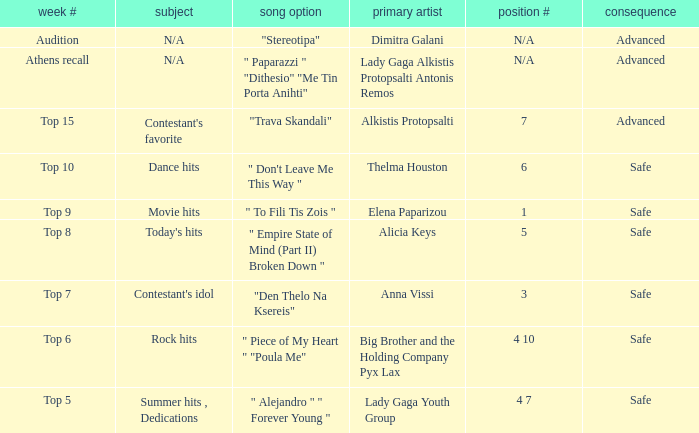What are all the order codes from the week "top 6"? 4 10. 